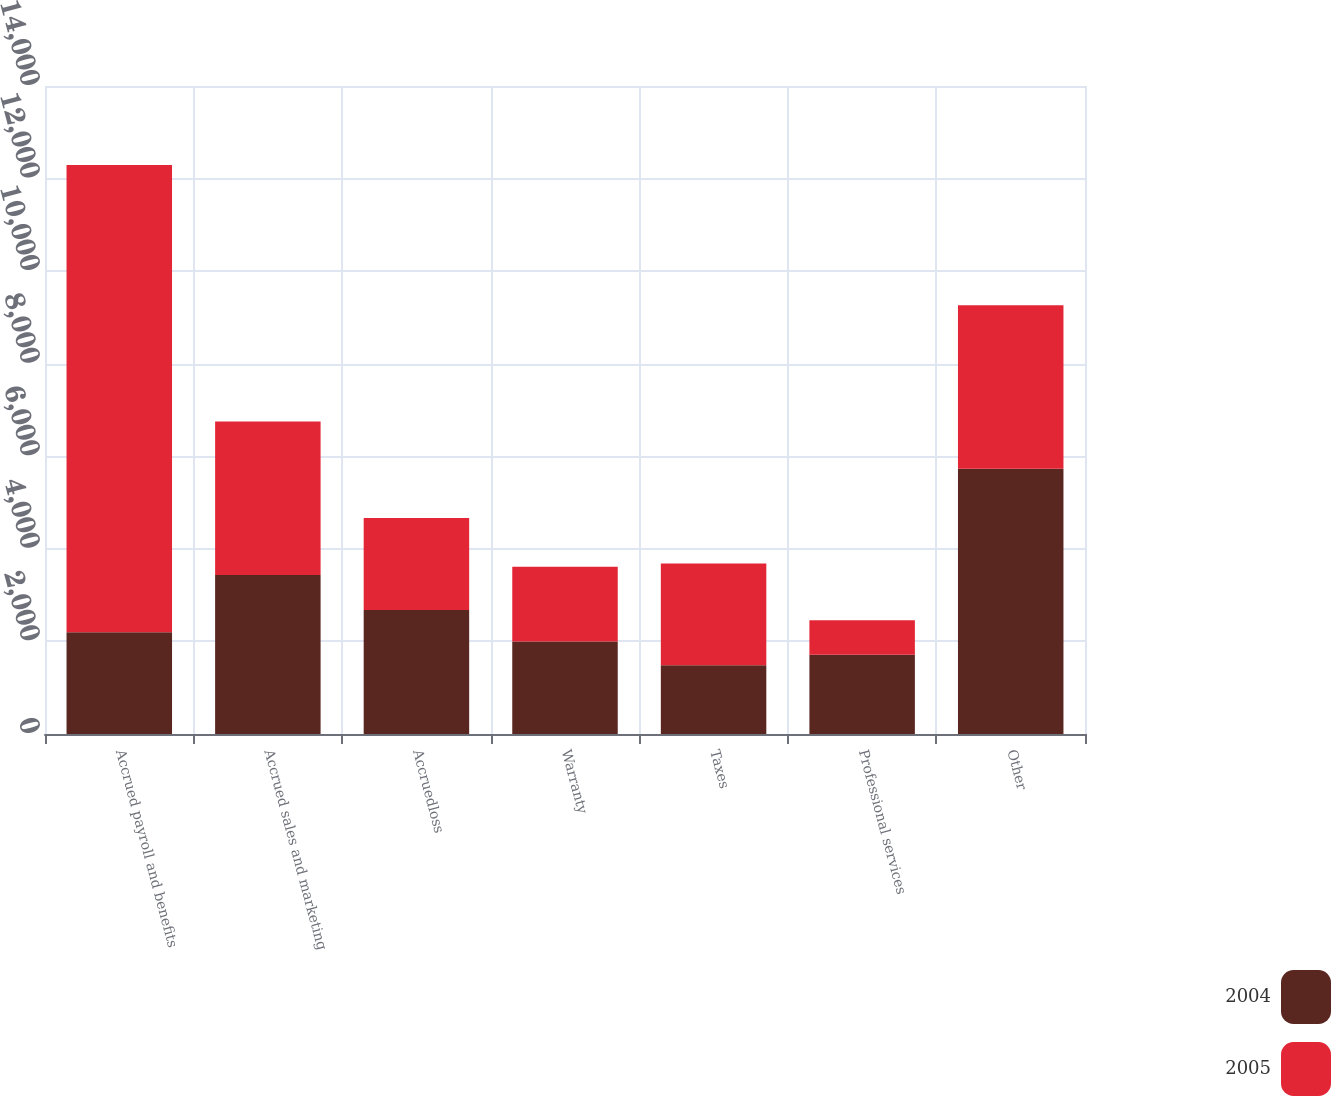Convert chart. <chart><loc_0><loc_0><loc_500><loc_500><stacked_bar_chart><ecel><fcel>Accrued payroll and benefits<fcel>Accrued sales and marketing<fcel>Accruedloss<fcel>Warranty<fcel>Taxes<fcel>Professional services<fcel>Other<nl><fcel>2004<fcel>2201<fcel>3437<fcel>2681<fcel>1998<fcel>1483<fcel>1713<fcel>5730<nl><fcel>2005<fcel>10090<fcel>3313<fcel>1985<fcel>1616<fcel>2201<fcel>745<fcel>3531<nl></chart> 